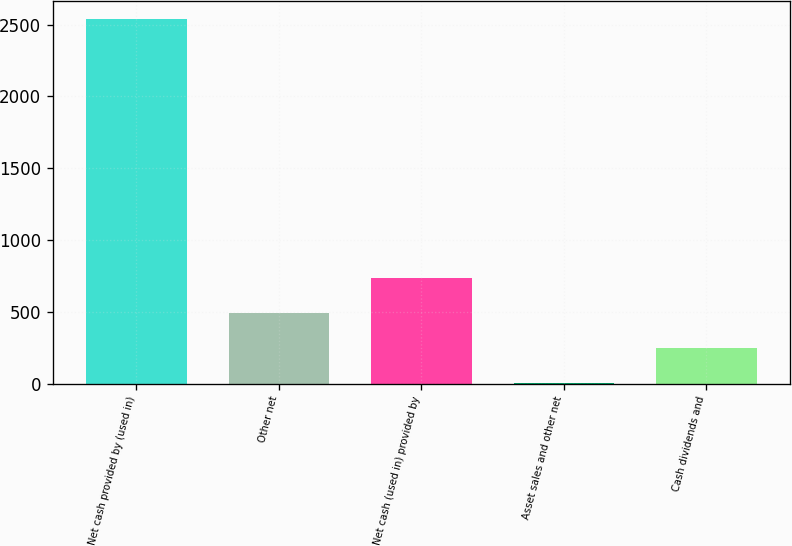Convert chart. <chart><loc_0><loc_0><loc_500><loc_500><bar_chart><fcel>Net cash provided by (used in)<fcel>Other net<fcel>Net cash (used in) provided by<fcel>Asset sales and other net<fcel>Cash dividends and<nl><fcel>2537.7<fcel>491.4<fcel>736.1<fcel>2<fcel>246.7<nl></chart> 